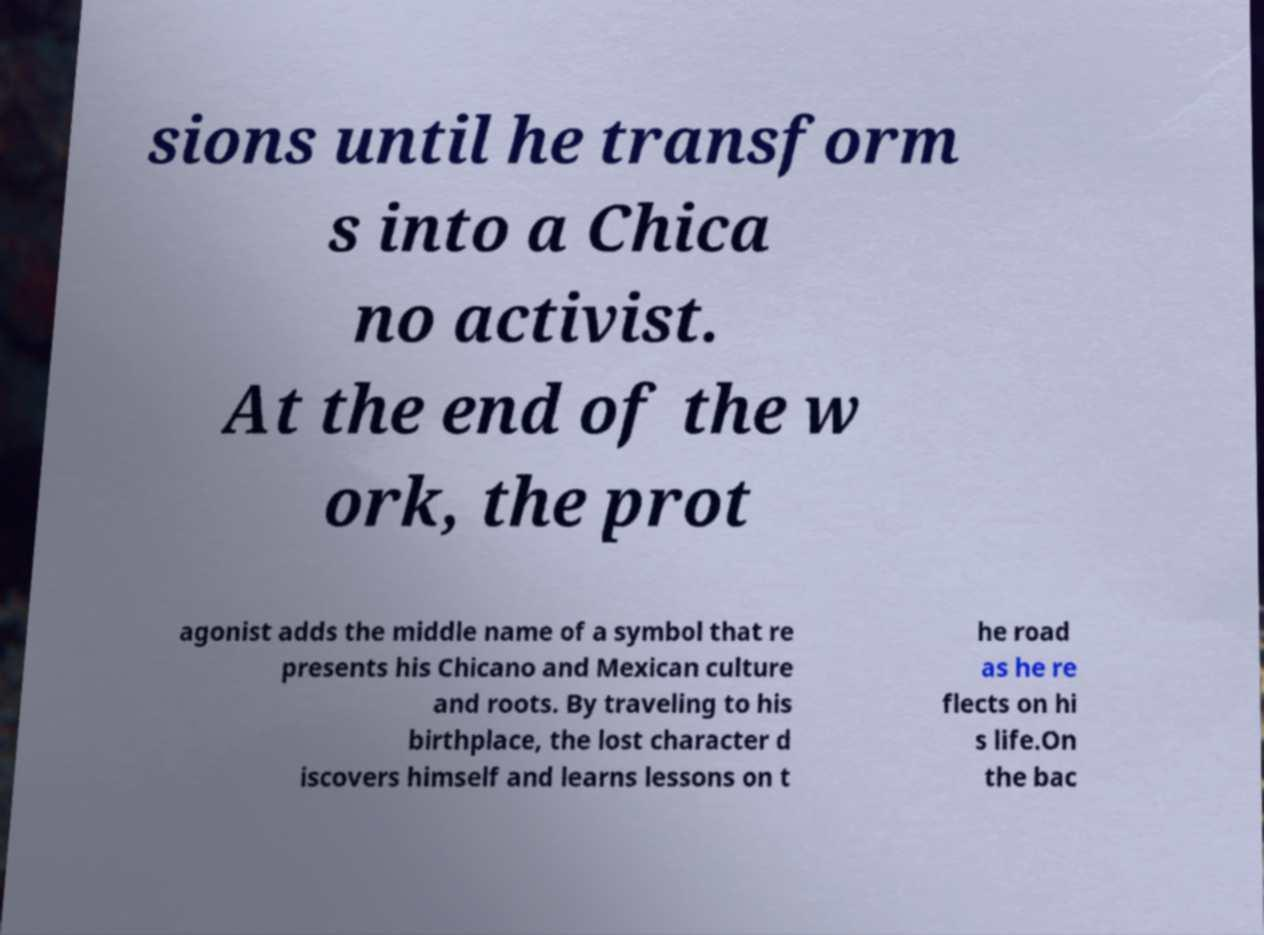Please identify and transcribe the text found in this image. sions until he transform s into a Chica no activist. At the end of the w ork, the prot agonist adds the middle name of a symbol that re presents his Chicano and Mexican culture and roots. By traveling to his birthplace, the lost character d iscovers himself and learns lessons on t he road as he re flects on hi s life.On the bac 